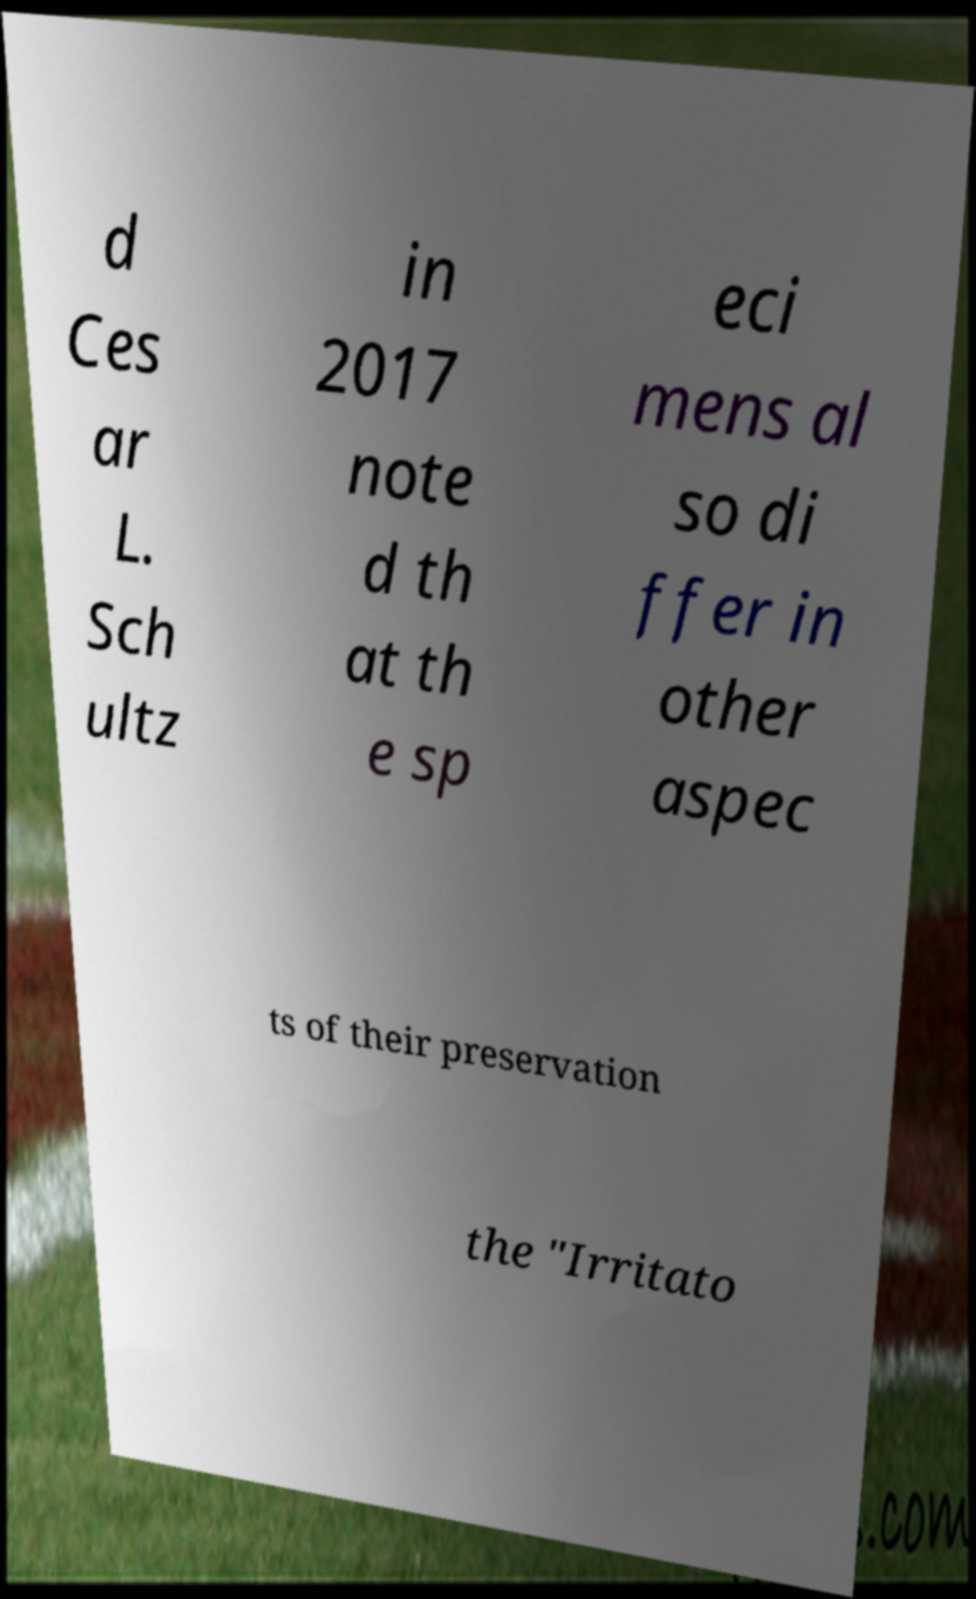Could you extract and type out the text from this image? d Ces ar L. Sch ultz in 2017 note d th at th e sp eci mens al so di ffer in other aspec ts of their preservation the "Irritato 